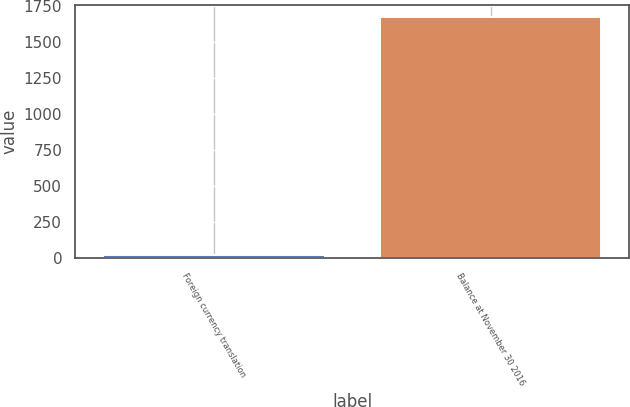Convert chart to OTSL. <chart><loc_0><loc_0><loc_500><loc_500><bar_chart><fcel>Foreign currency translation<fcel>Balance at November 30 2016<nl><fcel>23.9<fcel>1671.1<nl></chart> 